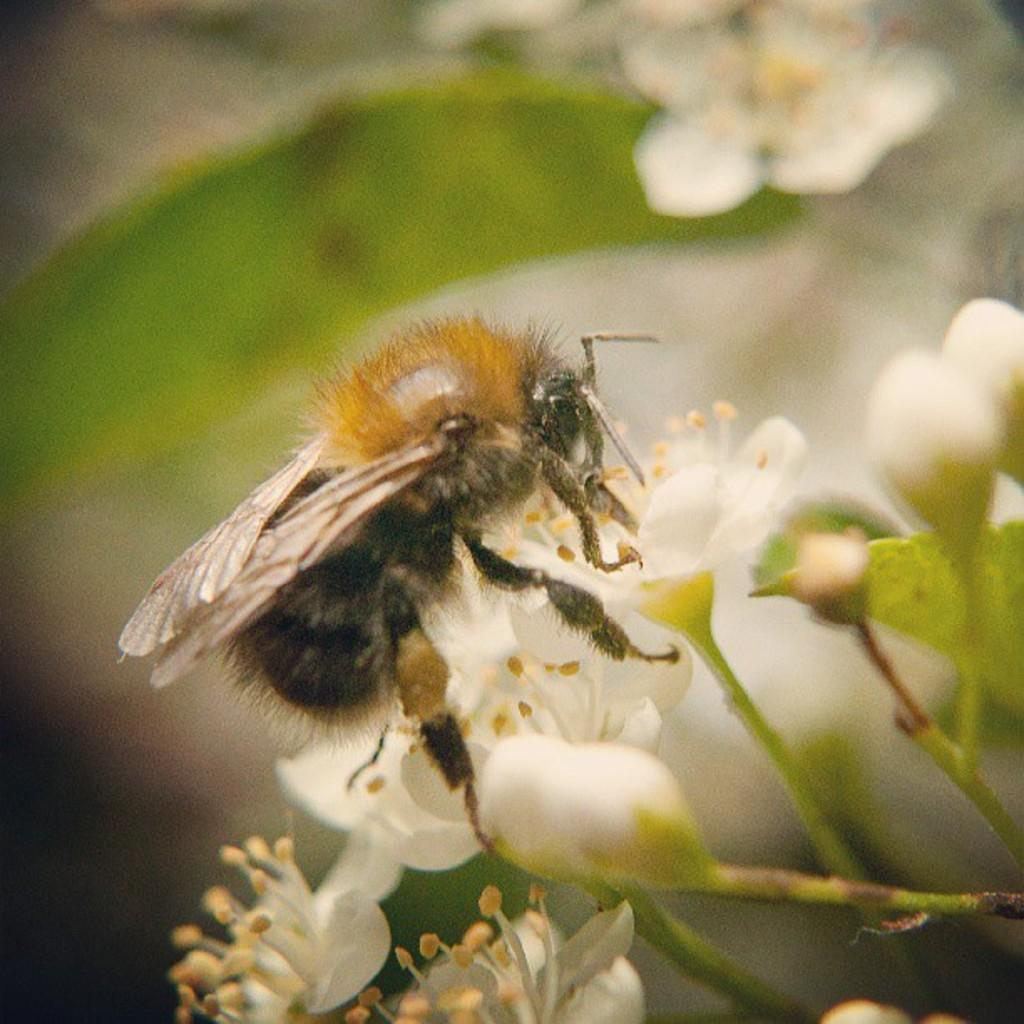What is the main subject of the image? There is a bee on a flower in the image. What else can be seen in the image besides the bee and flower? There are other plants and some buds in the image. What is visible in the background of the image? There are plants in the background of the image. What type of blood can be seen on the bee's stinger in the image? There is no blood visible on the bee's stinger in the image, and bees do not have stingers in their mouths. Who is the creator of the bee in the image? The image is a photograph, not a creation, so there is no creator of the bee in the image. 